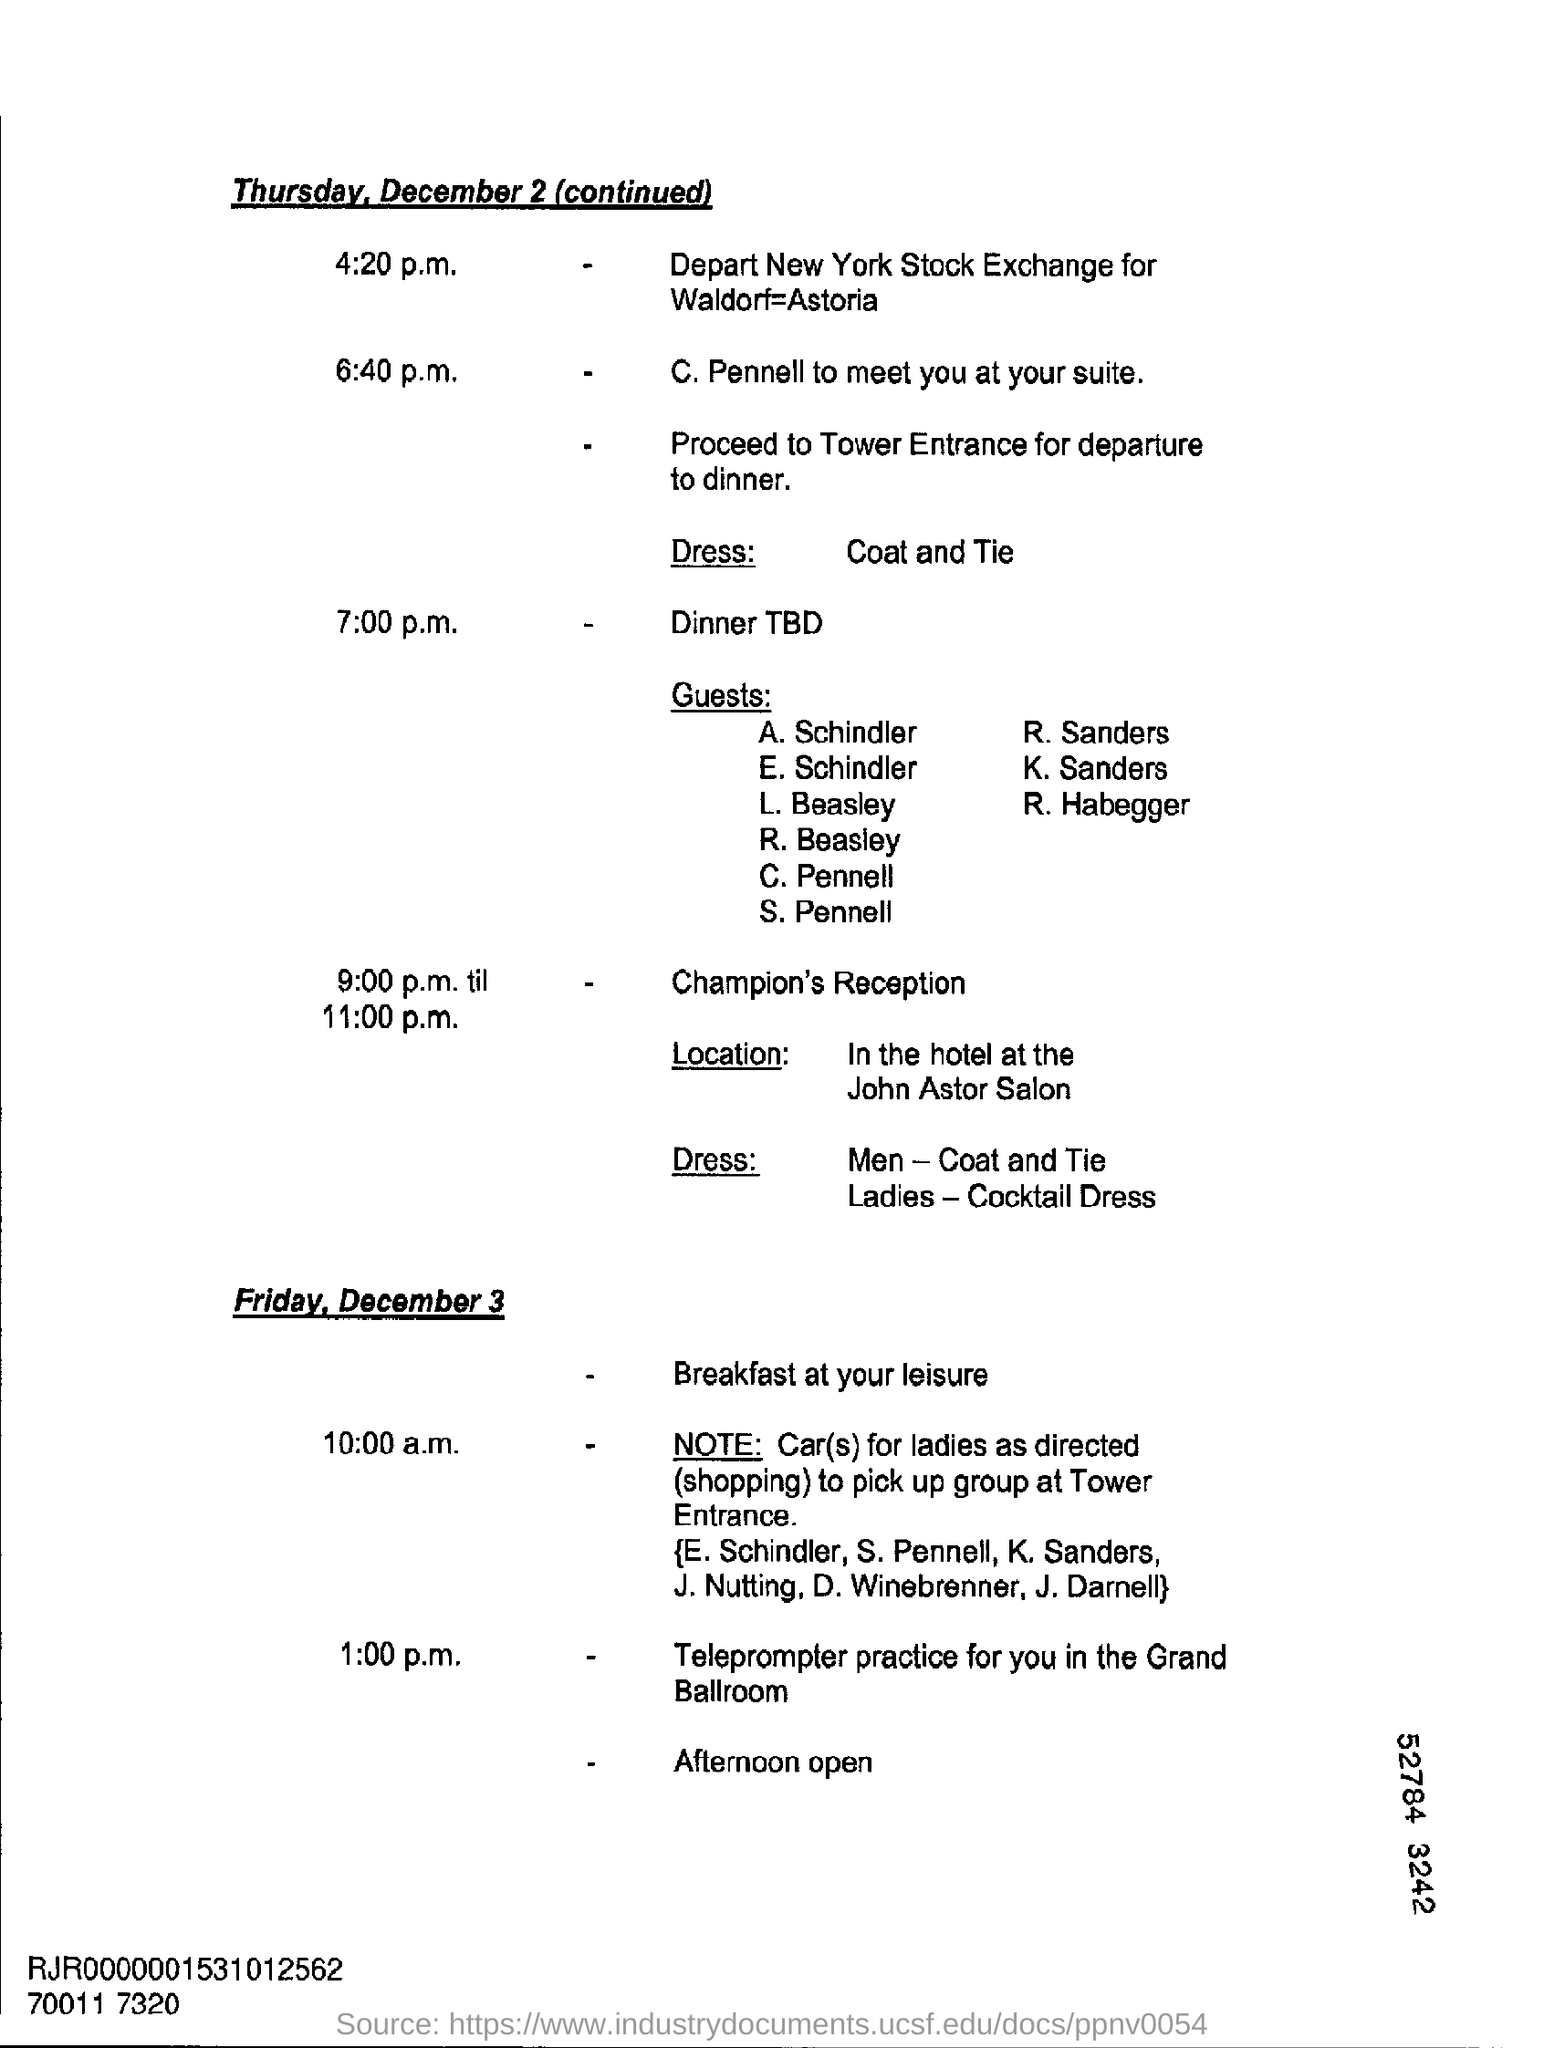What day of the week is december 2?
Offer a very short reply. Thursday. 